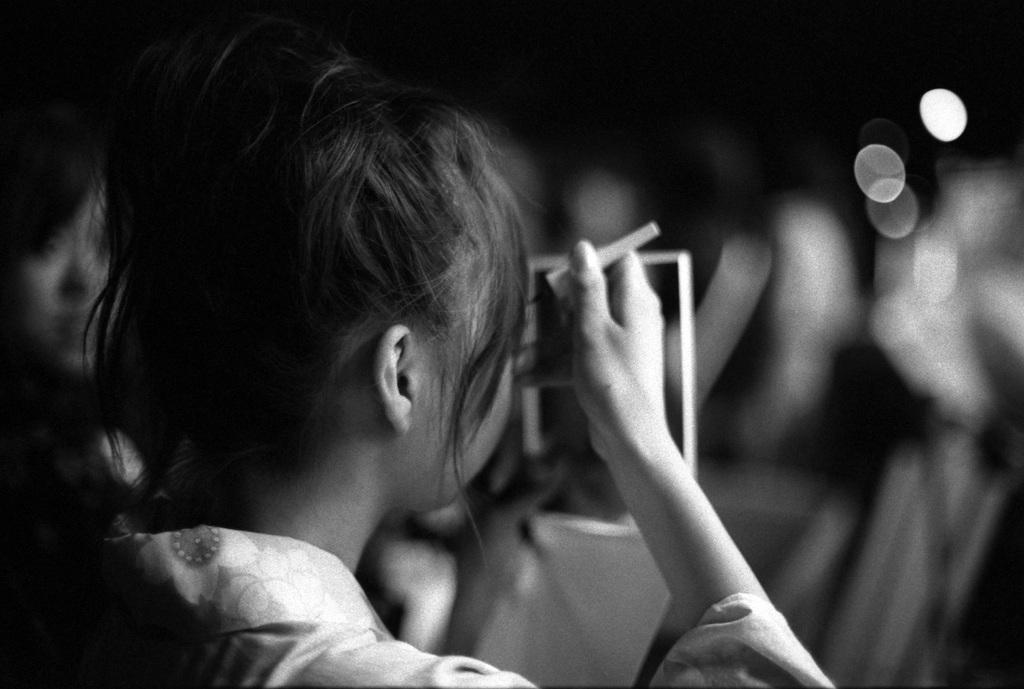What is the color scheme of the image? The image is black and white. Who is present in the image? There is a woman in the image. What is the woman doing in the image? The woman is applying kajal to her eyes. What object is present in the image that the woman is using? There is a mirror in the image, and the woman is looking into it. Can you see a snake in the image? No, there is no snake present in the image. 